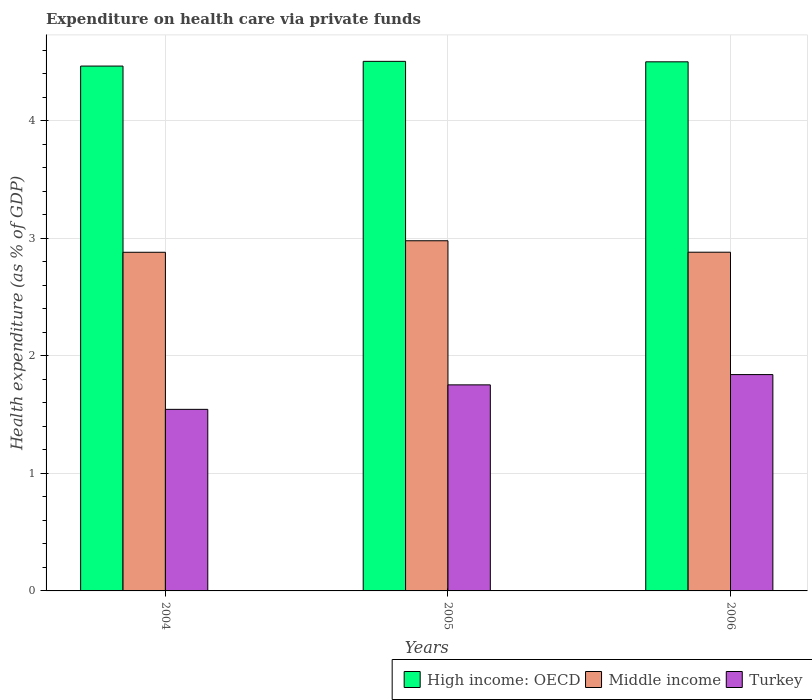How many groups of bars are there?
Provide a short and direct response. 3. Are the number of bars on each tick of the X-axis equal?
Make the answer very short. Yes. How many bars are there on the 2nd tick from the left?
Your answer should be very brief. 3. What is the expenditure made on health care in High income: OECD in 2005?
Offer a terse response. 4.5. Across all years, what is the maximum expenditure made on health care in Middle income?
Ensure brevity in your answer.  2.98. Across all years, what is the minimum expenditure made on health care in High income: OECD?
Keep it short and to the point. 4.46. What is the total expenditure made on health care in Turkey in the graph?
Provide a succinct answer. 5.14. What is the difference between the expenditure made on health care in Middle income in 2005 and that in 2006?
Your answer should be compact. 0.1. What is the difference between the expenditure made on health care in Middle income in 2005 and the expenditure made on health care in Turkey in 2004?
Provide a succinct answer. 1.43. What is the average expenditure made on health care in High income: OECD per year?
Offer a terse response. 4.49. In the year 2005, what is the difference between the expenditure made on health care in Turkey and expenditure made on health care in High income: OECD?
Give a very brief answer. -2.75. In how many years, is the expenditure made on health care in Turkey greater than 4.4 %?
Make the answer very short. 0. What is the ratio of the expenditure made on health care in High income: OECD in 2004 to that in 2006?
Provide a succinct answer. 0.99. Is the expenditure made on health care in High income: OECD in 2005 less than that in 2006?
Give a very brief answer. No. Is the difference between the expenditure made on health care in Turkey in 2005 and 2006 greater than the difference between the expenditure made on health care in High income: OECD in 2005 and 2006?
Your answer should be very brief. No. What is the difference between the highest and the second highest expenditure made on health care in High income: OECD?
Offer a very short reply. 0. What is the difference between the highest and the lowest expenditure made on health care in High income: OECD?
Provide a succinct answer. 0.04. Is the sum of the expenditure made on health care in High income: OECD in 2004 and 2005 greater than the maximum expenditure made on health care in Middle income across all years?
Give a very brief answer. Yes. What does the 3rd bar from the left in 2006 represents?
Your answer should be compact. Turkey. Is it the case that in every year, the sum of the expenditure made on health care in Middle income and expenditure made on health care in High income: OECD is greater than the expenditure made on health care in Turkey?
Your response must be concise. Yes. How many bars are there?
Offer a very short reply. 9. Are all the bars in the graph horizontal?
Provide a succinct answer. No. Does the graph contain grids?
Your answer should be very brief. Yes. Where does the legend appear in the graph?
Provide a succinct answer. Bottom right. How are the legend labels stacked?
Your response must be concise. Horizontal. What is the title of the graph?
Give a very brief answer. Expenditure on health care via private funds. Does "Arab World" appear as one of the legend labels in the graph?
Your response must be concise. No. What is the label or title of the Y-axis?
Your answer should be very brief. Health expenditure (as % of GDP). What is the Health expenditure (as % of GDP) in High income: OECD in 2004?
Your answer should be very brief. 4.46. What is the Health expenditure (as % of GDP) in Middle income in 2004?
Offer a very short reply. 2.88. What is the Health expenditure (as % of GDP) of Turkey in 2004?
Your answer should be compact. 1.54. What is the Health expenditure (as % of GDP) of High income: OECD in 2005?
Offer a very short reply. 4.5. What is the Health expenditure (as % of GDP) of Middle income in 2005?
Keep it short and to the point. 2.98. What is the Health expenditure (as % of GDP) of Turkey in 2005?
Offer a terse response. 1.75. What is the Health expenditure (as % of GDP) in High income: OECD in 2006?
Keep it short and to the point. 4.5. What is the Health expenditure (as % of GDP) of Middle income in 2006?
Make the answer very short. 2.88. What is the Health expenditure (as % of GDP) of Turkey in 2006?
Your response must be concise. 1.84. Across all years, what is the maximum Health expenditure (as % of GDP) in High income: OECD?
Ensure brevity in your answer.  4.5. Across all years, what is the maximum Health expenditure (as % of GDP) in Middle income?
Provide a succinct answer. 2.98. Across all years, what is the maximum Health expenditure (as % of GDP) in Turkey?
Give a very brief answer. 1.84. Across all years, what is the minimum Health expenditure (as % of GDP) in High income: OECD?
Provide a short and direct response. 4.46. Across all years, what is the minimum Health expenditure (as % of GDP) in Middle income?
Your answer should be very brief. 2.88. Across all years, what is the minimum Health expenditure (as % of GDP) in Turkey?
Give a very brief answer. 1.54. What is the total Health expenditure (as % of GDP) in High income: OECD in the graph?
Make the answer very short. 13.47. What is the total Health expenditure (as % of GDP) in Middle income in the graph?
Offer a terse response. 8.74. What is the total Health expenditure (as % of GDP) of Turkey in the graph?
Make the answer very short. 5.14. What is the difference between the Health expenditure (as % of GDP) in High income: OECD in 2004 and that in 2005?
Make the answer very short. -0.04. What is the difference between the Health expenditure (as % of GDP) of Middle income in 2004 and that in 2005?
Offer a terse response. -0.1. What is the difference between the Health expenditure (as % of GDP) in Turkey in 2004 and that in 2005?
Your answer should be compact. -0.21. What is the difference between the Health expenditure (as % of GDP) in High income: OECD in 2004 and that in 2006?
Provide a succinct answer. -0.04. What is the difference between the Health expenditure (as % of GDP) of Middle income in 2004 and that in 2006?
Offer a terse response. -0. What is the difference between the Health expenditure (as % of GDP) of Turkey in 2004 and that in 2006?
Your answer should be very brief. -0.3. What is the difference between the Health expenditure (as % of GDP) of High income: OECD in 2005 and that in 2006?
Offer a terse response. 0. What is the difference between the Health expenditure (as % of GDP) in Middle income in 2005 and that in 2006?
Keep it short and to the point. 0.1. What is the difference between the Health expenditure (as % of GDP) of Turkey in 2005 and that in 2006?
Keep it short and to the point. -0.09. What is the difference between the Health expenditure (as % of GDP) of High income: OECD in 2004 and the Health expenditure (as % of GDP) of Middle income in 2005?
Provide a short and direct response. 1.49. What is the difference between the Health expenditure (as % of GDP) of High income: OECD in 2004 and the Health expenditure (as % of GDP) of Turkey in 2005?
Keep it short and to the point. 2.71. What is the difference between the Health expenditure (as % of GDP) of Middle income in 2004 and the Health expenditure (as % of GDP) of Turkey in 2005?
Make the answer very short. 1.13. What is the difference between the Health expenditure (as % of GDP) of High income: OECD in 2004 and the Health expenditure (as % of GDP) of Middle income in 2006?
Your response must be concise. 1.58. What is the difference between the Health expenditure (as % of GDP) in High income: OECD in 2004 and the Health expenditure (as % of GDP) in Turkey in 2006?
Ensure brevity in your answer.  2.62. What is the difference between the Health expenditure (as % of GDP) of Middle income in 2004 and the Health expenditure (as % of GDP) of Turkey in 2006?
Provide a succinct answer. 1.04. What is the difference between the Health expenditure (as % of GDP) of High income: OECD in 2005 and the Health expenditure (as % of GDP) of Middle income in 2006?
Make the answer very short. 1.62. What is the difference between the Health expenditure (as % of GDP) in High income: OECD in 2005 and the Health expenditure (as % of GDP) in Turkey in 2006?
Provide a short and direct response. 2.66. What is the difference between the Health expenditure (as % of GDP) in Middle income in 2005 and the Health expenditure (as % of GDP) in Turkey in 2006?
Keep it short and to the point. 1.14. What is the average Health expenditure (as % of GDP) in High income: OECD per year?
Your response must be concise. 4.49. What is the average Health expenditure (as % of GDP) in Middle income per year?
Offer a very short reply. 2.91. What is the average Health expenditure (as % of GDP) in Turkey per year?
Offer a very short reply. 1.71. In the year 2004, what is the difference between the Health expenditure (as % of GDP) of High income: OECD and Health expenditure (as % of GDP) of Middle income?
Your response must be concise. 1.58. In the year 2004, what is the difference between the Health expenditure (as % of GDP) in High income: OECD and Health expenditure (as % of GDP) in Turkey?
Make the answer very short. 2.92. In the year 2004, what is the difference between the Health expenditure (as % of GDP) in Middle income and Health expenditure (as % of GDP) in Turkey?
Ensure brevity in your answer.  1.34. In the year 2005, what is the difference between the Health expenditure (as % of GDP) of High income: OECD and Health expenditure (as % of GDP) of Middle income?
Ensure brevity in your answer.  1.53. In the year 2005, what is the difference between the Health expenditure (as % of GDP) of High income: OECD and Health expenditure (as % of GDP) of Turkey?
Provide a succinct answer. 2.75. In the year 2005, what is the difference between the Health expenditure (as % of GDP) in Middle income and Health expenditure (as % of GDP) in Turkey?
Offer a terse response. 1.23. In the year 2006, what is the difference between the Health expenditure (as % of GDP) of High income: OECD and Health expenditure (as % of GDP) of Middle income?
Provide a succinct answer. 1.62. In the year 2006, what is the difference between the Health expenditure (as % of GDP) of High income: OECD and Health expenditure (as % of GDP) of Turkey?
Your answer should be very brief. 2.66. In the year 2006, what is the difference between the Health expenditure (as % of GDP) of Middle income and Health expenditure (as % of GDP) of Turkey?
Keep it short and to the point. 1.04. What is the ratio of the Health expenditure (as % of GDP) in Middle income in 2004 to that in 2005?
Offer a very short reply. 0.97. What is the ratio of the Health expenditure (as % of GDP) in Turkey in 2004 to that in 2005?
Keep it short and to the point. 0.88. What is the ratio of the Health expenditure (as % of GDP) of High income: OECD in 2004 to that in 2006?
Provide a succinct answer. 0.99. What is the ratio of the Health expenditure (as % of GDP) in Turkey in 2004 to that in 2006?
Your answer should be very brief. 0.84. What is the ratio of the Health expenditure (as % of GDP) in High income: OECD in 2005 to that in 2006?
Your answer should be compact. 1. What is the ratio of the Health expenditure (as % of GDP) of Middle income in 2005 to that in 2006?
Make the answer very short. 1.03. What is the ratio of the Health expenditure (as % of GDP) of Turkey in 2005 to that in 2006?
Provide a short and direct response. 0.95. What is the difference between the highest and the second highest Health expenditure (as % of GDP) of High income: OECD?
Give a very brief answer. 0. What is the difference between the highest and the second highest Health expenditure (as % of GDP) in Middle income?
Your response must be concise. 0.1. What is the difference between the highest and the second highest Health expenditure (as % of GDP) in Turkey?
Provide a succinct answer. 0.09. What is the difference between the highest and the lowest Health expenditure (as % of GDP) of High income: OECD?
Ensure brevity in your answer.  0.04. What is the difference between the highest and the lowest Health expenditure (as % of GDP) in Middle income?
Your answer should be very brief. 0.1. What is the difference between the highest and the lowest Health expenditure (as % of GDP) in Turkey?
Give a very brief answer. 0.3. 